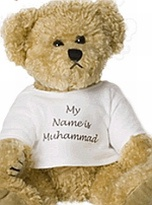Describe the objects in this image and their specific colors. I can see a teddy bear in lightgray, tan, and white tones in this image. 